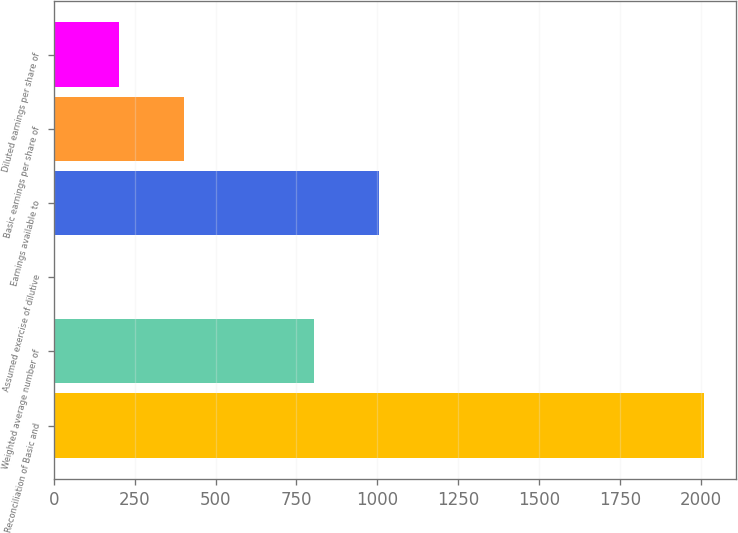Convert chart to OTSL. <chart><loc_0><loc_0><loc_500><loc_500><bar_chart><fcel>Reconciliation of Basic and<fcel>Weighted average number of<fcel>Assumed exercise of dilutive<fcel>Earnings available to<fcel>Basic earnings per share of<fcel>Diluted earnings per share of<nl><fcel>2009<fcel>804.8<fcel>2<fcel>1005.5<fcel>403.4<fcel>202.7<nl></chart> 